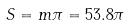Convert formula to latex. <formula><loc_0><loc_0><loc_500><loc_500>S = m \pi = 5 3 . 8 \pi</formula> 